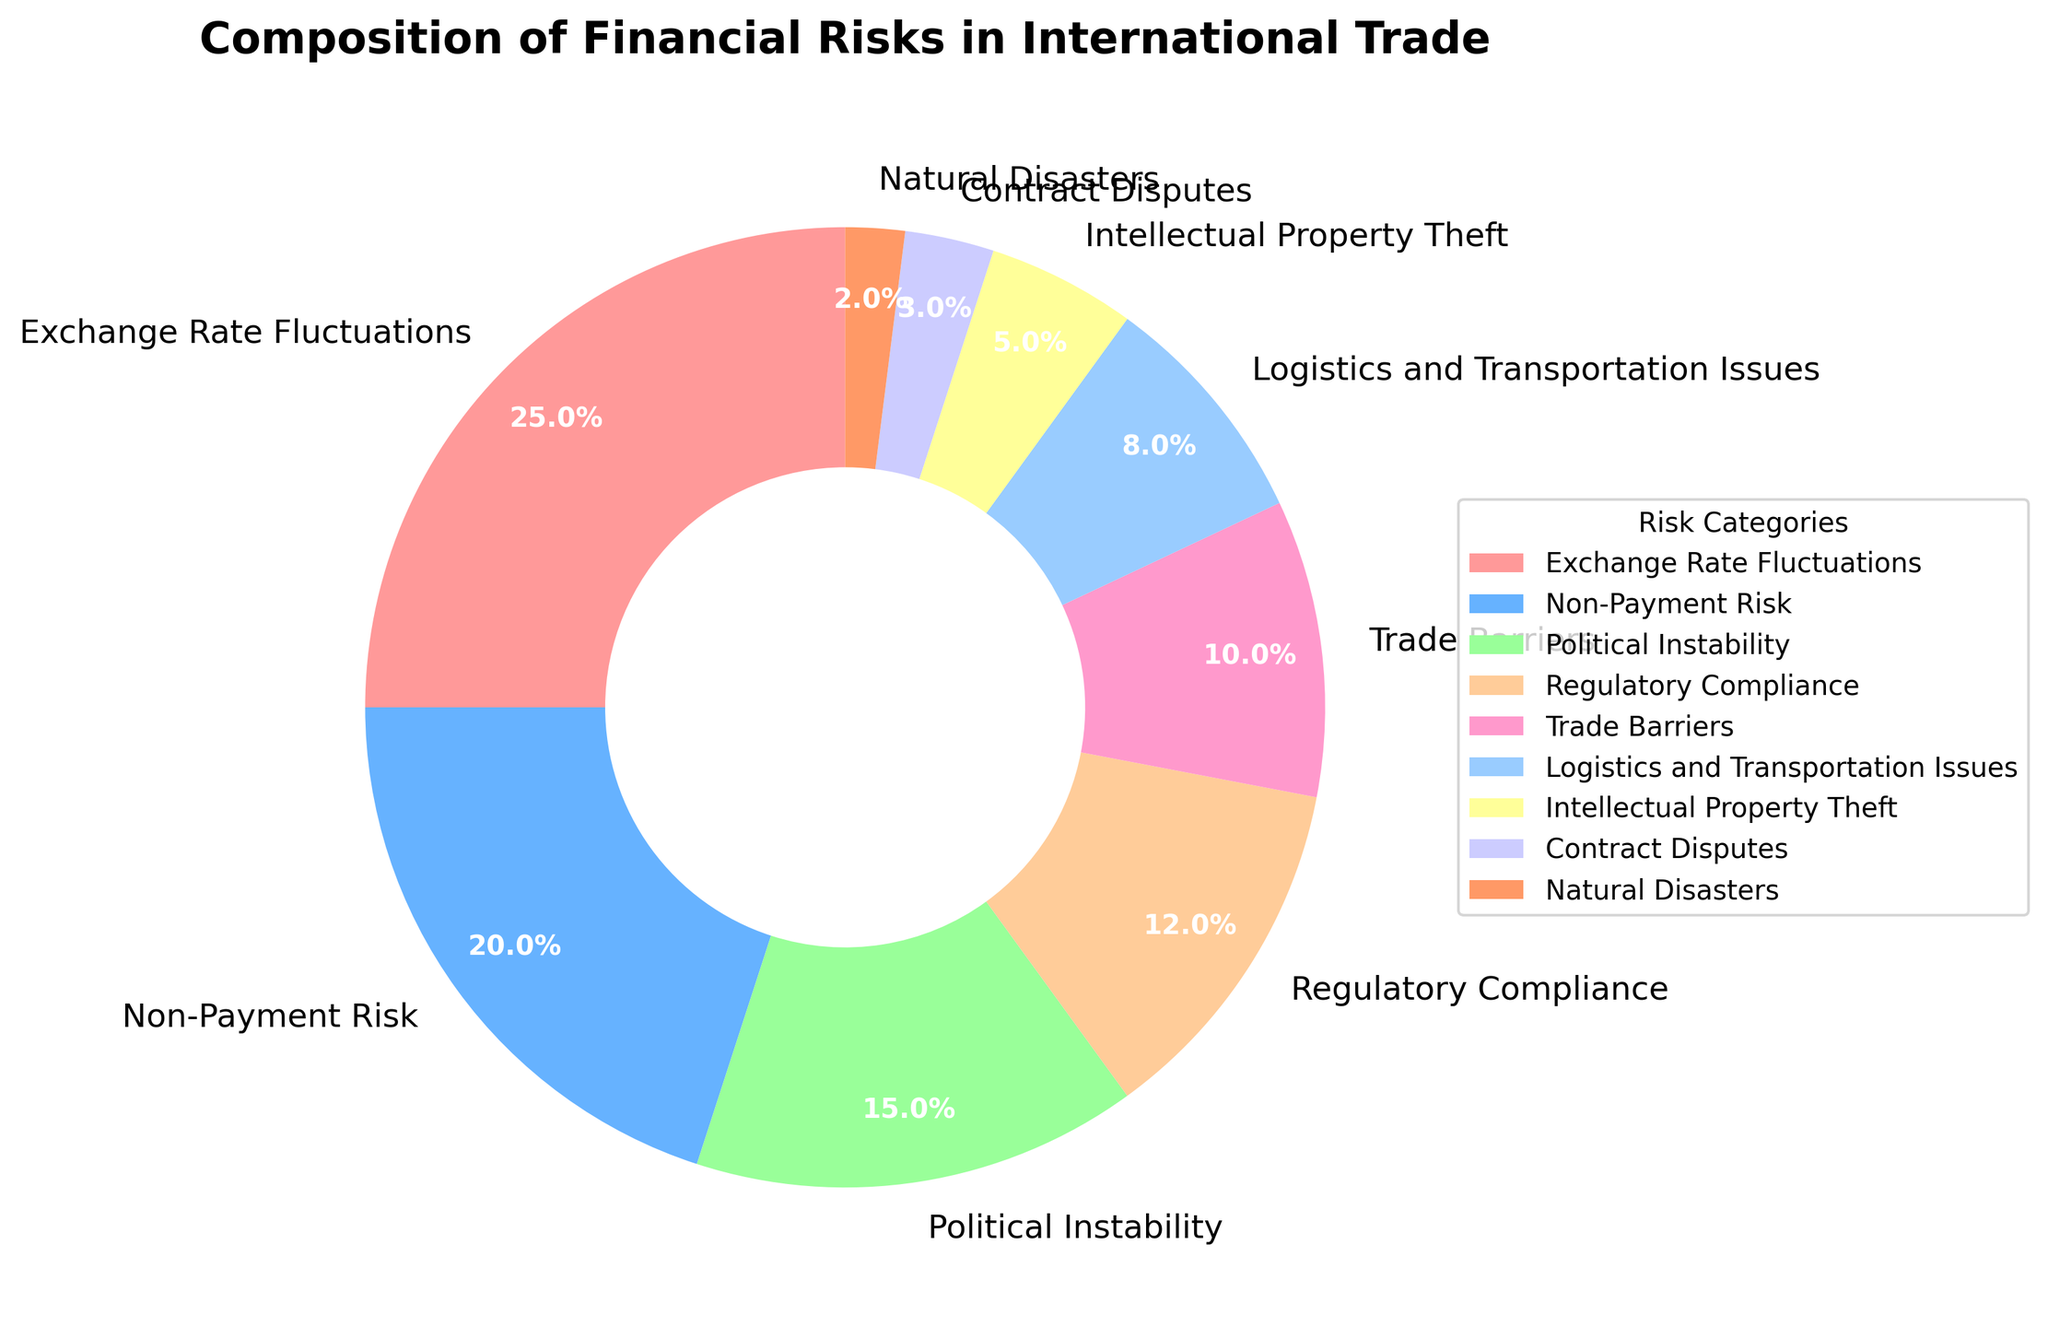What is the total percentage of risks attributed to Exchange Rate Fluctuations, Non-Payment Risk, and Political Instability combined? To find the total percentage of these three categories, sum their individual percentages: Exchange Rate Fluctuations (25%), Non-Payment Risk (20%), and Political Instability (15%). So, 25% + 20% + 15% = 60%
Answer: 60% Which risk category represents the highest percentage in the composition? To determine the category with the highest percentage, compare all the percentages given. Exchange Rate Fluctuations has the highest at 25%.
Answer: Exchange Rate Fluctuations How does the percentage of Regulatory Compliance compare to Logistics and Transportation Issues? To compare these two categories, look at their percentages. Regulatory Compliance is at 12%, and Logistics and Transportation Issues are at 8%. Therefore, Regulatory Compliance is greater.
Answer: Regulatory Compliance is greater What is the difference in percentage between Trade Barriers and Intellectual Property Theft? To find the difference, subtract the smaller percentage from the larger. Trade Barriers is 10% and Intellectual Property Theft is 5%. So, 10% - 5% = 5%.
Answer: 5% What color is used to represent Trade Barriers in the chart? Referring to the pie chart, the color used for Trade Barriers can be identified visually.
Answer: Peach (assuming #FFCC99) Which risk category is represented by the smallest slice in the pie chart? To find the smallest slice, look for the smallest percentage in the data. Natural Disasters are represented by 2%, which is the smallest.
Answer: Natural Disasters How many total categories are shown in the pie chart? Count the number of different risk categories listed in the chart. There are nine categories listed.
Answer: 9 What is the combined percentage of Contract Disputes and Natural Disasters? Sum the percentages of Contract Disputes (3%) and Natural Disasters (2%). So, 3% + 2% = 5%.
Answer: 5% How does the percentage of Exchange Rate Fluctuations compare to Non-Payment Risk and Political Instability combined? Sum the percentages of Non-Payment Risk (20%) and Political Instability (15%). 20% + 15% = 35%. Compare this with Exchange Rate Fluctuations (25%). 25% is less than 35%.
Answer: Less than 35% What is the median percentage value for all risk categories? List the percentages in ascending order and find the middle value. The sorted percentages are: 2%, 3%, 5%, 8%, 10%, 12%, 15%, 20%, and 25%. The median value (middle one) is 10%.
Answer: 10% 